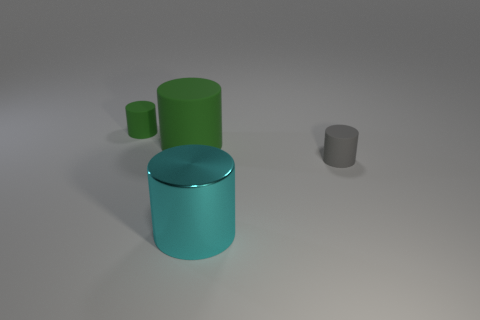Subtract 1 cylinders. How many cylinders are left? 3 Add 2 shiny cylinders. How many objects exist? 6 Subtract 1 gray cylinders. How many objects are left? 3 Subtract all gray matte objects. Subtract all big green cylinders. How many objects are left? 2 Add 2 large green rubber cylinders. How many large green rubber cylinders are left? 3 Add 3 cyan metal cylinders. How many cyan metal cylinders exist? 4 